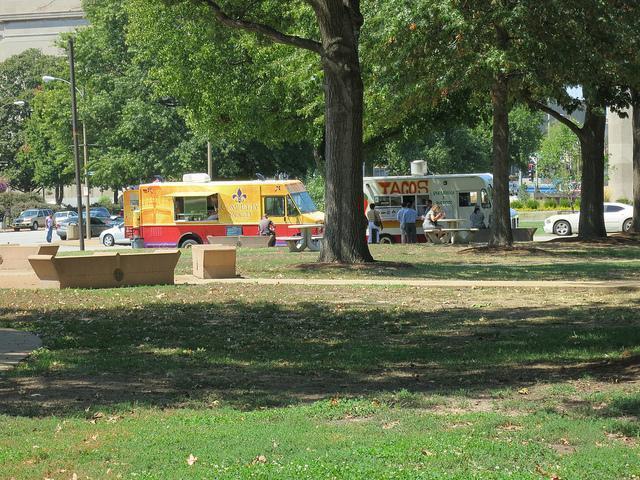What is the yellow truck doing?
From the following four choices, select the correct answer to address the question.
Options: Transporting goods, receiving donation, mobile library, selling food. Selling food. 